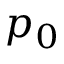Convert formula to latex. <formula><loc_0><loc_0><loc_500><loc_500>p _ { 0 }</formula> 